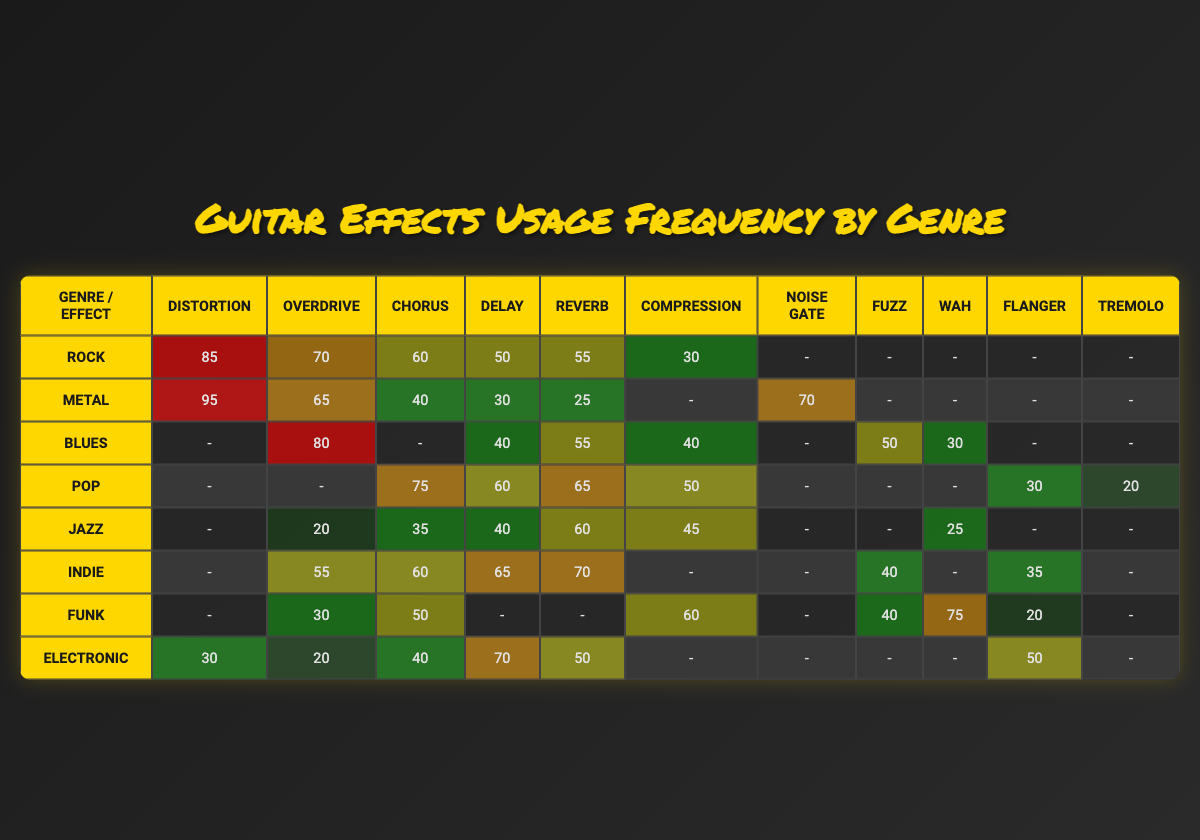What is the frequency of "Chorus" usage in the "Pop" genre? According to the table, the usage frequency of "Chorus" in the "Pop" genre is clearly stated as 75.
Answer: 75 Which genre has the highest frequency of "Distortion" usage? The "Metal" genre shows the highest frequency of "Distortion" with a value of 95, which is higher than any other genre in the table.
Answer: Metal What is the difference in usage frequency of "Overdrive" between "Blues" and "Jazz"? The usage frequency of "Overdrive" in "Blues" is 80 while in "Jazz" it is 20. Therefore, the difference is 80 - 20 = 60.
Answer: 60 Does the "Electronic" genre use "Fuzz"? The table indicates that the "Electronic" genre has no value listed for "Fuzz," implying it is not used in this genre.
Answer: No Which genre has the lowest overall usage of effects? To determine this, I can analyze the usage frequencies across all effects for each genre. The total for "Jazz" is 20 + 35 + 40 + 60 + 45 + 25 = 225, which is lower than all other genres when summed.
Answer: Jazz What is the average frequency of "Delay" usage across all genres? First, I total the "Delay" values: 50 (Rock) + 30 (Metal) + 40 (Blues) + 60 (Pop) + 40 (Jazz) + 65 (Indie) + 0 (Funk) + 70 (Electronic) = 395. There are 8 genres, so the average is 395/8 ≈ 49.38.
Answer: 49.38 In which genres is "Compression" used more than 50? Examining the table shows that "Compression" is used more than 50 in "Rock" (30), "Blues" (40), "Funk" (60), and "Indie" (not used), making these values 60 or above for "Funk".
Answer: Funk Is "Wah" used in the "Metal" genre? The table displays a "-" under "Wah" for "Metal", which indicates that this effect is not used in this genre.
Answer: No What is the percentage frequency of "Delay" in the "Indie" genre compared to the highest frequency of "Chorus"? The "Delay" usage in "Indie" is 65, while the highest frequency of "Chorus", which is 75 from the "Pop" genre. So, calculating the percentage gives (65/75) * 100 = 86.67%.
Answer: 86.67 